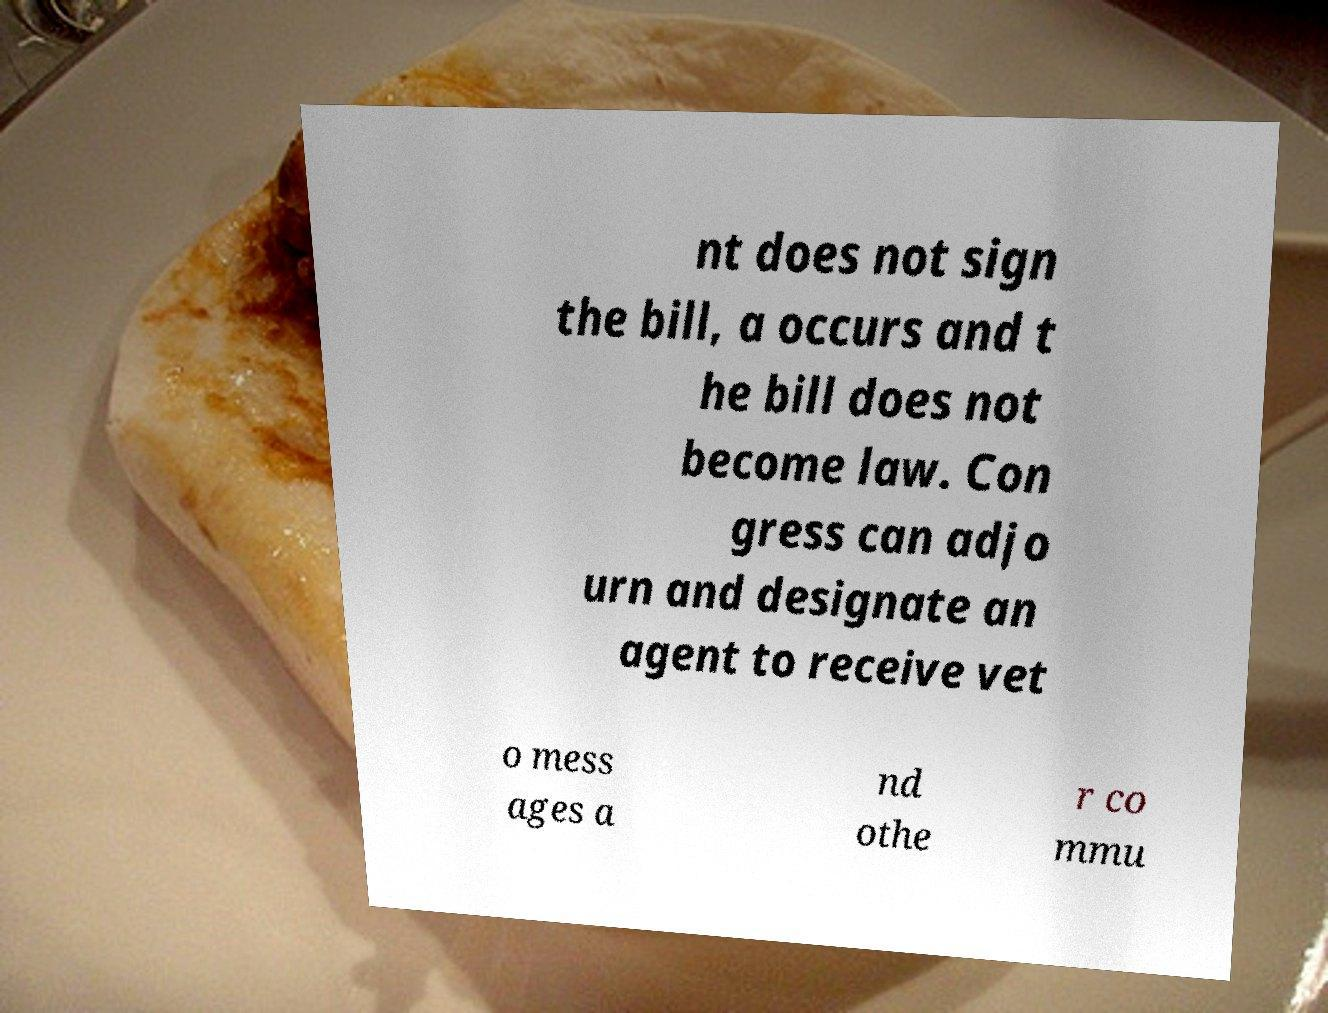What messages or text are displayed in this image? I need them in a readable, typed format. nt does not sign the bill, a occurs and t he bill does not become law. Con gress can adjo urn and designate an agent to receive vet o mess ages a nd othe r co mmu 